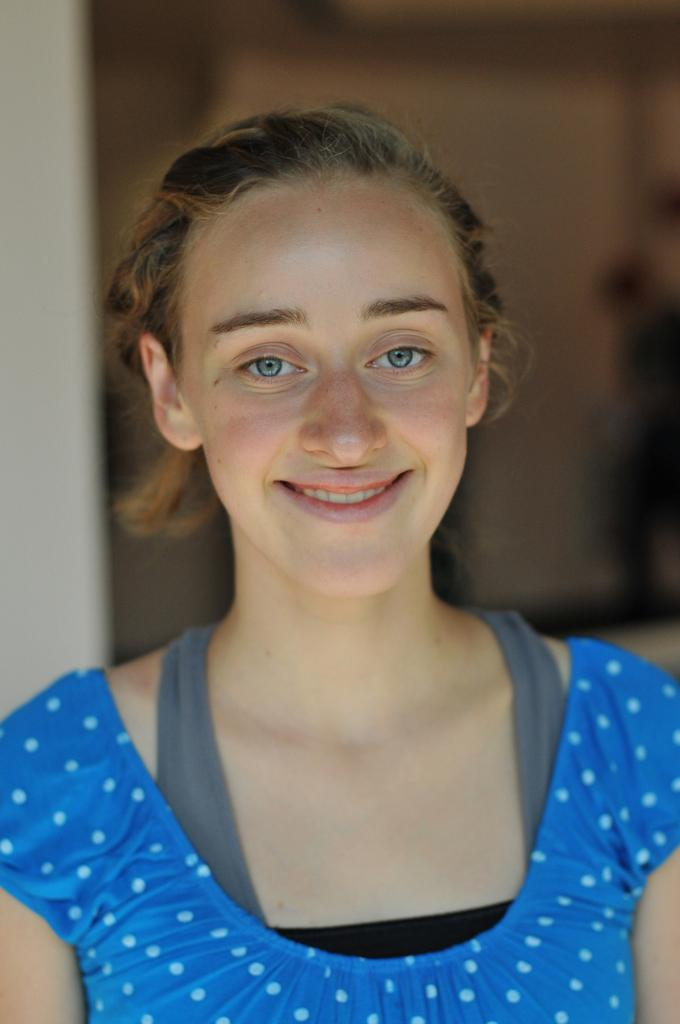Who is the main subject in the image? There is a woman in the image. What is the woman wearing? The woman is wearing a blue dress. What expression does the woman have? The woman is smiling. Can you describe the background of the image? The background of the image is blurred. Can you see the woman's friend and the lake in the background of the image? There is no friend or lake present in the image; it only features a woman in a blue dress with a blurred background. 